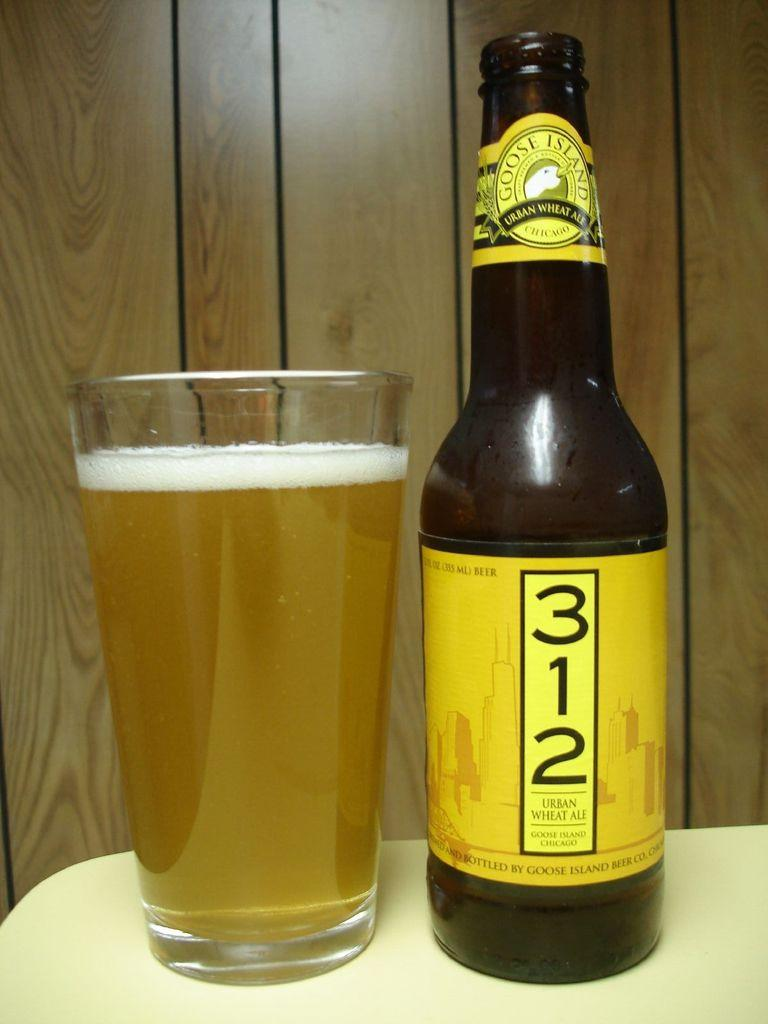<image>
Create a compact narrative representing the image presented. A bottle of 312 urban wheat ale is on a yellow table next to a full glass. 